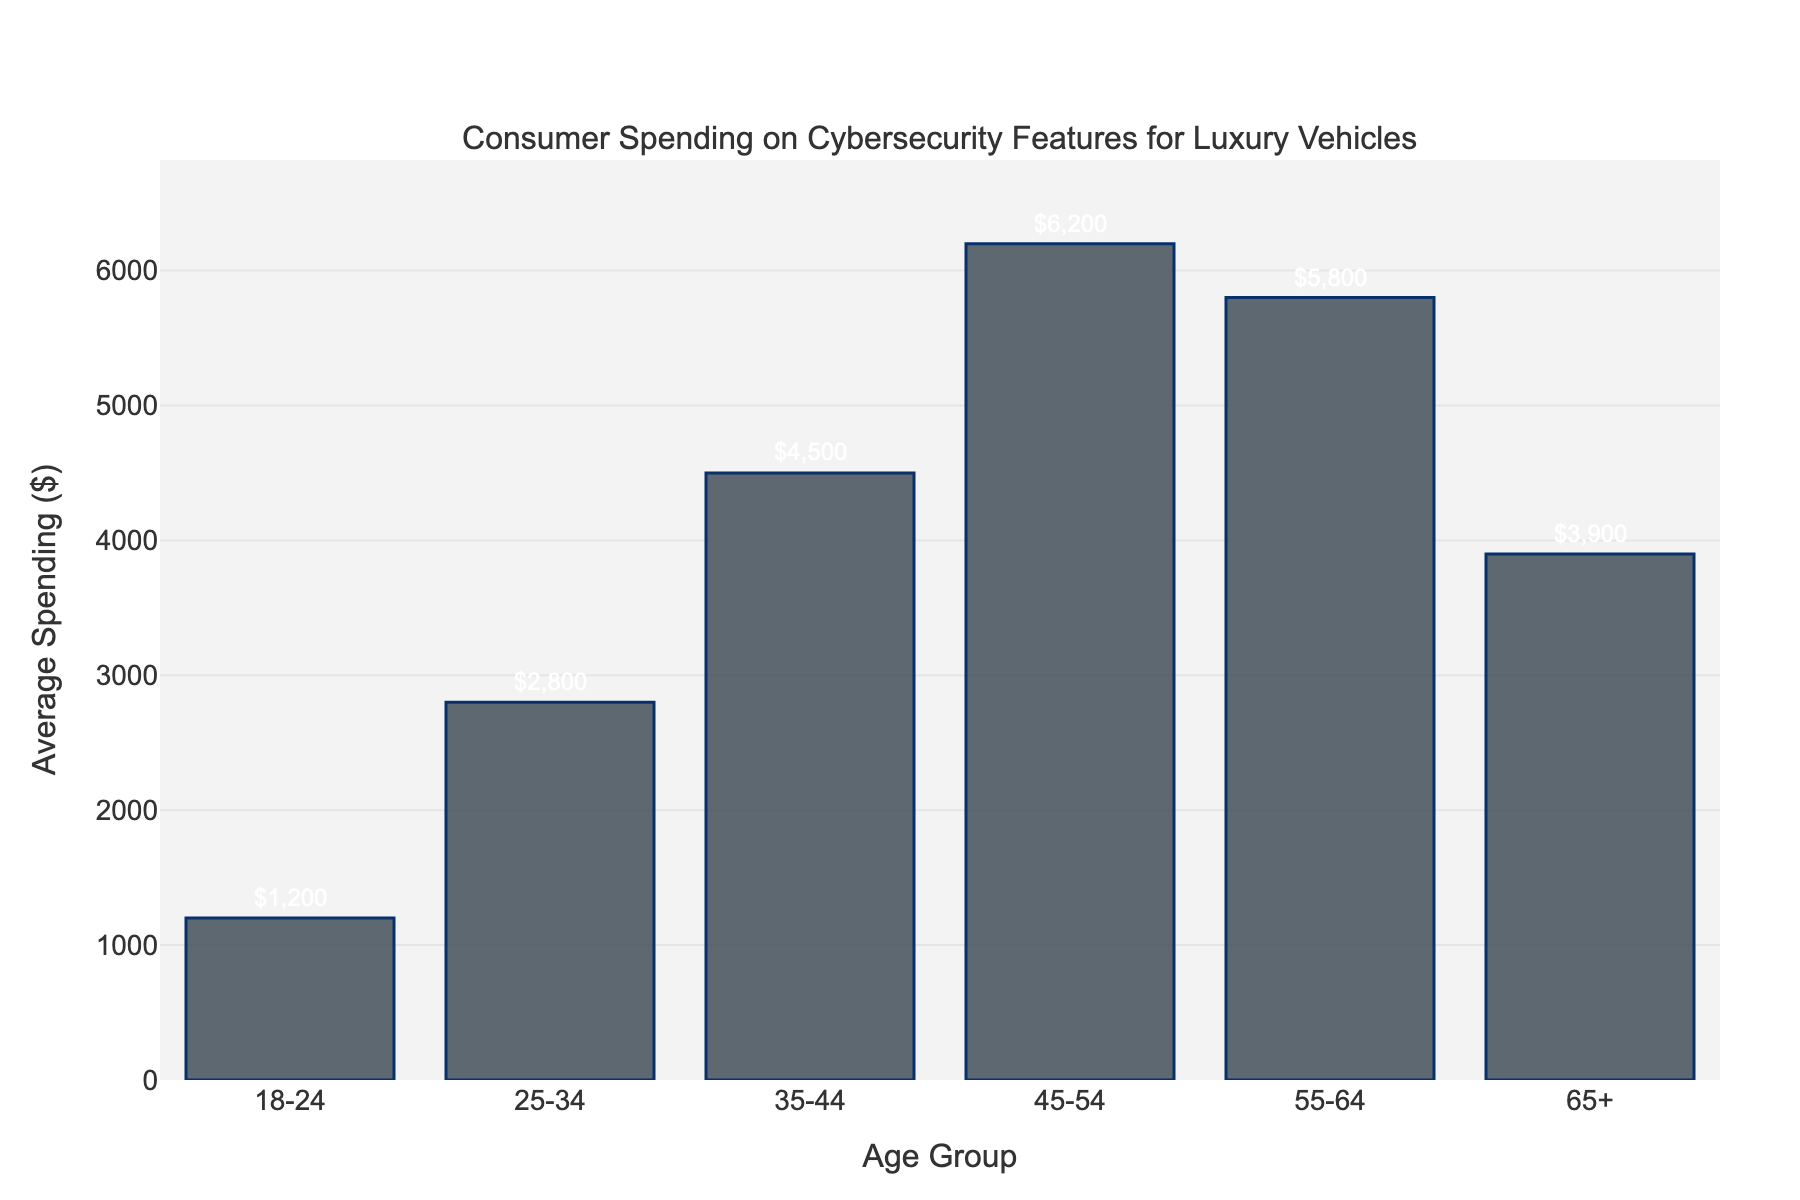What is the age group with the highest average spending on cybersecurity features for luxury vehicles? The bar chart shows that the 45-54 age group has the highest bar.
Answer: 45-54 What is the difference in average spending between the age group 25-34 and 65+? The bar chart shows the average spending for ages 25-34 is $2800 and for ages 65+ is $3900. The difference is $3900 - $2800 .
Answer: $1100 How does the average spending of the 35-44 age group compare to the 55-64 age group? The 35-44 age group has an average spending of $4500, and the 55-64 age group has $5800. By comparing the heights of the bars, the 55-64 age group spends more.
Answer: 55-64 spends more Which age group spends the least on cybersecurity features for luxury vehicles? The bar chart shows that the 18-24 age group has the shortest bar.
Answer: 18-24 What is the total average spending of the age groups 35-44 and 45-54 combined? The average spending for the 35-44 age group is $4500, and for the 45-54 age group is $6200. Adding these values gives $4500 + $6200.
Answer: $10700 How much more does the 45-54 age group spend on average compared to the 18-24 age group? The average spending for the 45-54 age group is $6200, and for the 18-24 age group is $1200. The difference is $6200 - $1200.
Answer: $5000 What is the average spending difference between the youngest (18-24) and oldest (65+) age groups? The average spending for the 18-24 age group is $1200, and for the 65+ age group is $3900. The difference is $3900 - $1200.
Answer: $2700 Which age group has a higher average spending: 25-34 or 35-44? The average spending for the 25-34 age group is $2800, and for the 35-44 age group is $4500. The 35-44 age group has a higher bar.
Answer: 35-44 Among the age groups listed, which two have the closest average spending amounts? By observing the heights of the bars, the 55-64 ($5800) and 65+ ($3900) age groups are not the closest. The closest are 18-24 and 25-34 with spending of $1200 and $2800 respectively, with a difference of $1600. However, the closest in amount are 25-34 ($2800) and 65+ ($3900) with a difference of $1100.
Answer: 25-34 and 65+ Rank the age groups from highest to lowest average spending on cybersecurity. The bars indicate the following ranking from highest to lowest: 45-54 ($6200), 55-64 ($5800), 35-44 ($4500), 65+ ($3900), 25-34 ($2800), 18-24 ($1200).
Answer: 45-54, 55-64, 35-44, 65+, 25-34, 18-24 